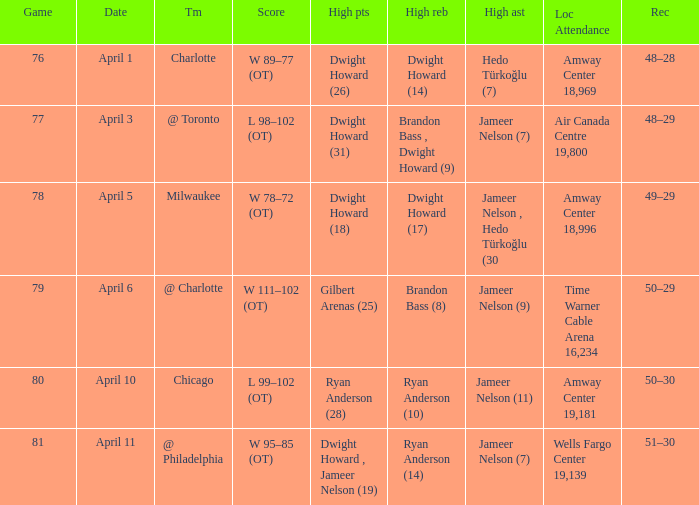Who secured the most rebounds on april 1, and what was their total amount? Dwight Howard (14). 